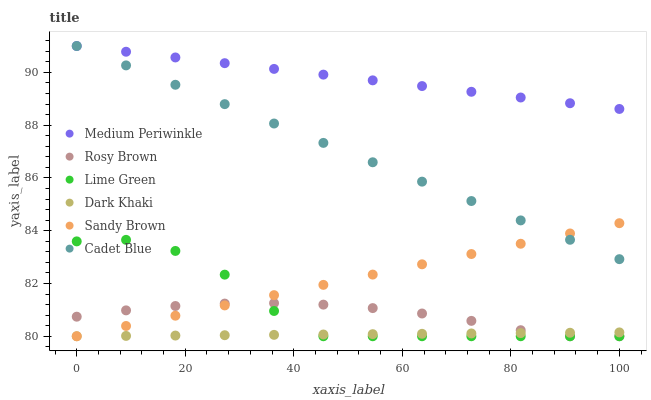Does Dark Khaki have the minimum area under the curve?
Answer yes or no. Yes. Does Medium Periwinkle have the maximum area under the curve?
Answer yes or no. Yes. Does Sandy Brown have the minimum area under the curve?
Answer yes or no. No. Does Sandy Brown have the maximum area under the curve?
Answer yes or no. No. Is Cadet Blue the smoothest?
Answer yes or no. Yes. Is Lime Green the roughest?
Answer yes or no. Yes. Is Sandy Brown the smoothest?
Answer yes or no. No. Is Sandy Brown the roughest?
Answer yes or no. No. Does Sandy Brown have the lowest value?
Answer yes or no. Yes. Does Medium Periwinkle have the lowest value?
Answer yes or no. No. Does Medium Periwinkle have the highest value?
Answer yes or no. Yes. Does Sandy Brown have the highest value?
Answer yes or no. No. Is Lime Green less than Cadet Blue?
Answer yes or no. Yes. Is Medium Periwinkle greater than Dark Khaki?
Answer yes or no. Yes. Does Sandy Brown intersect Rosy Brown?
Answer yes or no. Yes. Is Sandy Brown less than Rosy Brown?
Answer yes or no. No. Is Sandy Brown greater than Rosy Brown?
Answer yes or no. No. Does Lime Green intersect Cadet Blue?
Answer yes or no. No. 